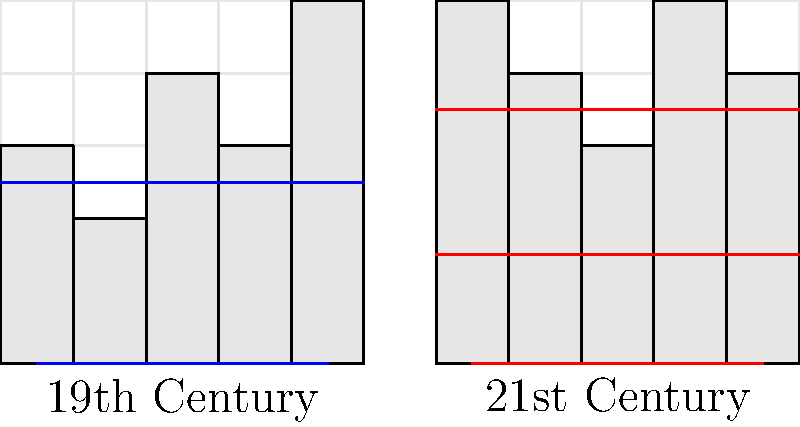Based on the simplified city maps comparing 19th and 21st century urban layouts, which key change in street planning is most evident? To answer this question, let's analyze the key differences between the 19th and 21st century city layouts:

1. Street layout:
   - 19th century: Two main streets (blue lines), one horizontal and one vertical
   - 21st century: Three main streets (red lines), all horizontal

2. Building heights:
   - 19th century: Varied heights, generally lower
   - 21st century: Taller buildings with more consistent heights

3. Street density:
   - 19th century: Fewer main streets
   - 21st century: More main streets, indicating increased connectivity

4. Grid system:
   - Both layouts use a grid system, but the 21st century map shows a more developed grid

The most significant change evident in the street planning is the increase in horizontal streets in the 21st century layout. This change reflects a shift towards improved connectivity and accessibility in modern urban planning.
Answer: Increased horizontal street density 